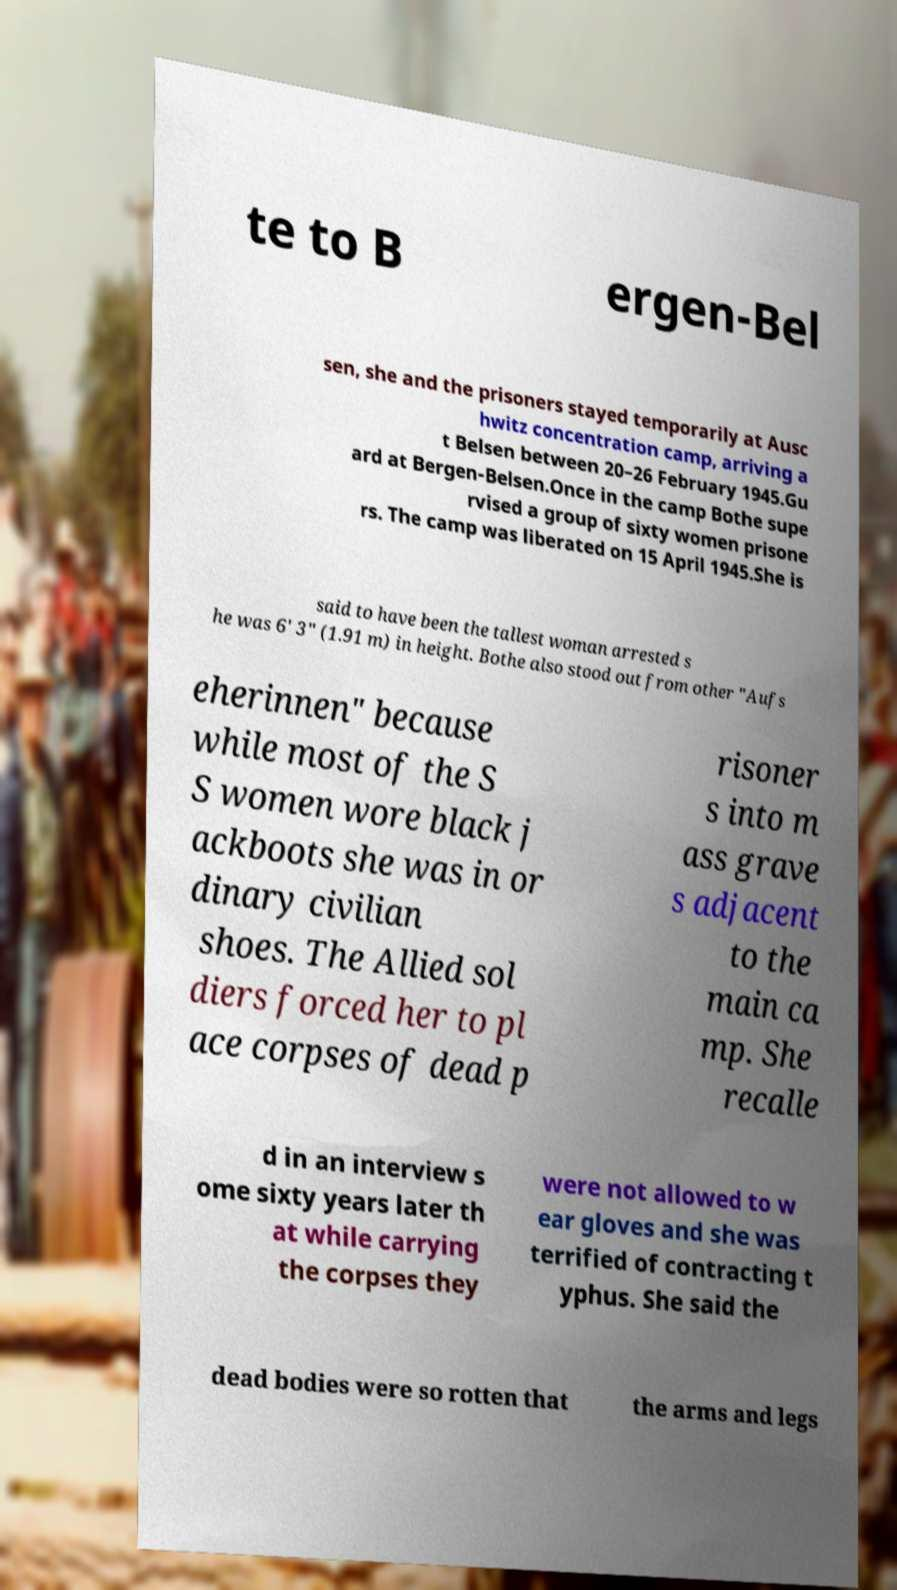What messages or text are displayed in this image? I need them in a readable, typed format. te to B ergen-Bel sen, she and the prisoners stayed temporarily at Ausc hwitz concentration camp, arriving a t Belsen between 20–26 February 1945.Gu ard at Bergen-Belsen.Once in the camp Bothe supe rvised a group of sixty women prisone rs. The camp was liberated on 15 April 1945.She is said to have been the tallest woman arrested s he was 6' 3" (1.91 m) in height. Bothe also stood out from other "Aufs eherinnen" because while most of the S S women wore black j ackboots she was in or dinary civilian shoes. The Allied sol diers forced her to pl ace corpses of dead p risoner s into m ass grave s adjacent to the main ca mp. She recalle d in an interview s ome sixty years later th at while carrying the corpses they were not allowed to w ear gloves and she was terrified of contracting t yphus. She said the dead bodies were so rotten that the arms and legs 